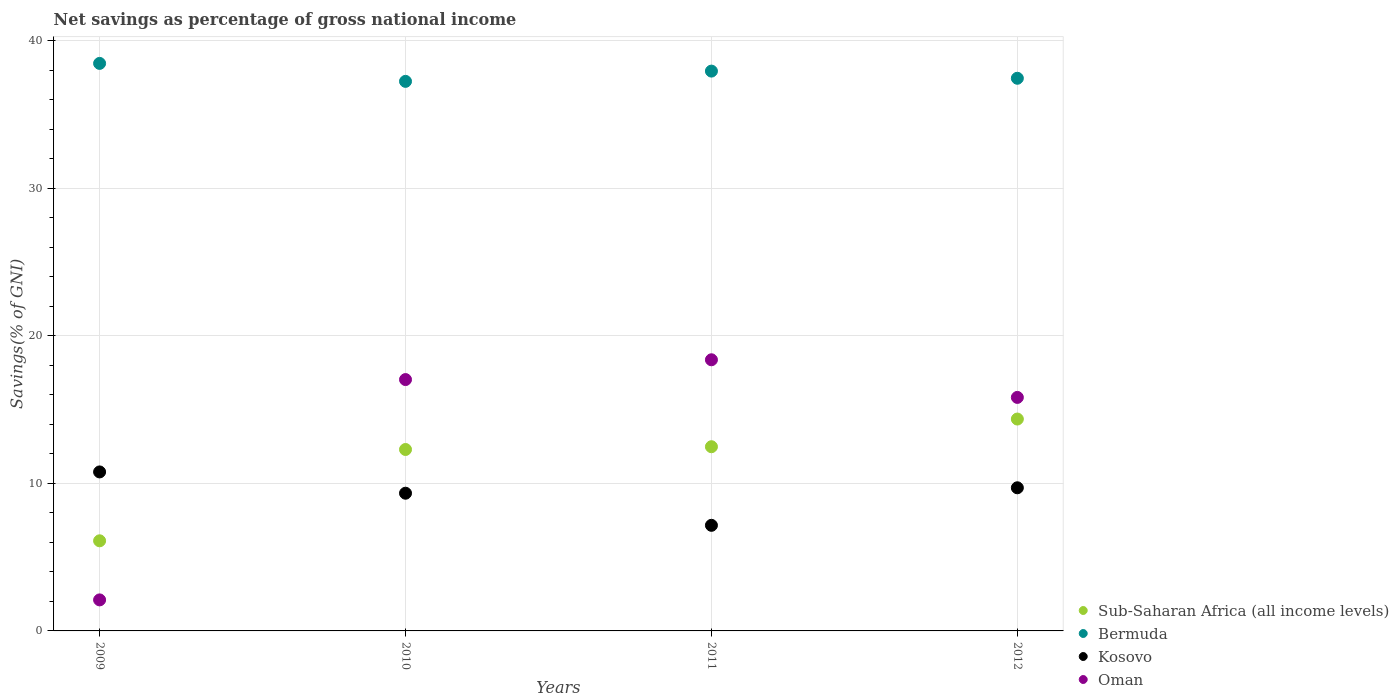How many different coloured dotlines are there?
Ensure brevity in your answer.  4. Is the number of dotlines equal to the number of legend labels?
Your answer should be compact. Yes. What is the total savings in Sub-Saharan Africa (all income levels) in 2010?
Your answer should be compact. 12.3. Across all years, what is the maximum total savings in Bermuda?
Give a very brief answer. 38.46. Across all years, what is the minimum total savings in Kosovo?
Ensure brevity in your answer.  7.16. In which year was the total savings in Oman maximum?
Your answer should be very brief. 2011. In which year was the total savings in Kosovo minimum?
Provide a short and direct response. 2011. What is the total total savings in Kosovo in the graph?
Offer a very short reply. 36.96. What is the difference between the total savings in Oman in 2010 and that in 2011?
Your answer should be compact. -1.34. What is the difference between the total savings in Kosovo in 2012 and the total savings in Oman in 2010?
Your answer should be very brief. -7.33. What is the average total savings in Oman per year?
Your answer should be very brief. 13.33. In the year 2009, what is the difference between the total savings in Oman and total savings in Bermuda?
Provide a short and direct response. -36.36. What is the ratio of the total savings in Kosovo in 2010 to that in 2012?
Provide a succinct answer. 0.96. What is the difference between the highest and the second highest total savings in Sub-Saharan Africa (all income levels)?
Provide a short and direct response. 1.88. What is the difference between the highest and the lowest total savings in Bermuda?
Keep it short and to the point. 1.22. Is the sum of the total savings in Kosovo in 2010 and 2012 greater than the maximum total savings in Oman across all years?
Make the answer very short. Yes. Is it the case that in every year, the sum of the total savings in Bermuda and total savings in Oman  is greater than the total savings in Kosovo?
Your answer should be compact. Yes. Does the total savings in Sub-Saharan Africa (all income levels) monotonically increase over the years?
Your response must be concise. Yes. How many years are there in the graph?
Keep it short and to the point. 4. What is the difference between two consecutive major ticks on the Y-axis?
Keep it short and to the point. 10. Are the values on the major ticks of Y-axis written in scientific E-notation?
Offer a terse response. No. Does the graph contain any zero values?
Offer a very short reply. No. How many legend labels are there?
Make the answer very short. 4. How are the legend labels stacked?
Ensure brevity in your answer.  Vertical. What is the title of the graph?
Give a very brief answer. Net savings as percentage of gross national income. What is the label or title of the Y-axis?
Your answer should be very brief. Savings(% of GNI). What is the Savings(% of GNI) in Sub-Saharan Africa (all income levels) in 2009?
Your answer should be very brief. 6.11. What is the Savings(% of GNI) of Bermuda in 2009?
Your answer should be compact. 38.46. What is the Savings(% of GNI) in Kosovo in 2009?
Keep it short and to the point. 10.77. What is the Savings(% of GNI) in Oman in 2009?
Offer a terse response. 2.1. What is the Savings(% of GNI) in Sub-Saharan Africa (all income levels) in 2010?
Ensure brevity in your answer.  12.3. What is the Savings(% of GNI) in Bermuda in 2010?
Keep it short and to the point. 37.24. What is the Savings(% of GNI) in Kosovo in 2010?
Make the answer very short. 9.33. What is the Savings(% of GNI) in Oman in 2010?
Your response must be concise. 17.03. What is the Savings(% of GNI) of Sub-Saharan Africa (all income levels) in 2011?
Offer a terse response. 12.48. What is the Savings(% of GNI) of Bermuda in 2011?
Ensure brevity in your answer.  37.94. What is the Savings(% of GNI) in Kosovo in 2011?
Offer a terse response. 7.16. What is the Savings(% of GNI) in Oman in 2011?
Provide a short and direct response. 18.38. What is the Savings(% of GNI) of Sub-Saharan Africa (all income levels) in 2012?
Your answer should be compact. 14.36. What is the Savings(% of GNI) in Bermuda in 2012?
Give a very brief answer. 37.45. What is the Savings(% of GNI) of Kosovo in 2012?
Your response must be concise. 9.7. What is the Savings(% of GNI) of Oman in 2012?
Your response must be concise. 15.83. Across all years, what is the maximum Savings(% of GNI) of Sub-Saharan Africa (all income levels)?
Make the answer very short. 14.36. Across all years, what is the maximum Savings(% of GNI) in Bermuda?
Provide a succinct answer. 38.46. Across all years, what is the maximum Savings(% of GNI) of Kosovo?
Ensure brevity in your answer.  10.77. Across all years, what is the maximum Savings(% of GNI) in Oman?
Provide a succinct answer. 18.38. Across all years, what is the minimum Savings(% of GNI) in Sub-Saharan Africa (all income levels)?
Offer a terse response. 6.11. Across all years, what is the minimum Savings(% of GNI) of Bermuda?
Ensure brevity in your answer.  37.24. Across all years, what is the minimum Savings(% of GNI) of Kosovo?
Offer a very short reply. 7.16. Across all years, what is the minimum Savings(% of GNI) of Oman?
Keep it short and to the point. 2.1. What is the total Savings(% of GNI) in Sub-Saharan Africa (all income levels) in the graph?
Make the answer very short. 45.24. What is the total Savings(% of GNI) of Bermuda in the graph?
Offer a very short reply. 151.09. What is the total Savings(% of GNI) in Kosovo in the graph?
Offer a very short reply. 36.96. What is the total Savings(% of GNI) of Oman in the graph?
Offer a terse response. 53.34. What is the difference between the Savings(% of GNI) in Sub-Saharan Africa (all income levels) in 2009 and that in 2010?
Offer a very short reply. -6.19. What is the difference between the Savings(% of GNI) in Bermuda in 2009 and that in 2010?
Your answer should be very brief. 1.22. What is the difference between the Savings(% of GNI) in Kosovo in 2009 and that in 2010?
Your response must be concise. 1.44. What is the difference between the Savings(% of GNI) of Oman in 2009 and that in 2010?
Ensure brevity in your answer.  -14.93. What is the difference between the Savings(% of GNI) in Sub-Saharan Africa (all income levels) in 2009 and that in 2011?
Offer a very short reply. -6.38. What is the difference between the Savings(% of GNI) in Bermuda in 2009 and that in 2011?
Provide a succinct answer. 0.52. What is the difference between the Savings(% of GNI) of Kosovo in 2009 and that in 2011?
Ensure brevity in your answer.  3.62. What is the difference between the Savings(% of GNI) in Oman in 2009 and that in 2011?
Your answer should be very brief. -16.27. What is the difference between the Savings(% of GNI) of Sub-Saharan Africa (all income levels) in 2009 and that in 2012?
Offer a very short reply. -8.25. What is the difference between the Savings(% of GNI) in Bermuda in 2009 and that in 2012?
Provide a short and direct response. 1.01. What is the difference between the Savings(% of GNI) in Kosovo in 2009 and that in 2012?
Offer a very short reply. 1.07. What is the difference between the Savings(% of GNI) of Oman in 2009 and that in 2012?
Offer a terse response. -13.72. What is the difference between the Savings(% of GNI) in Sub-Saharan Africa (all income levels) in 2010 and that in 2011?
Your response must be concise. -0.19. What is the difference between the Savings(% of GNI) of Bermuda in 2010 and that in 2011?
Provide a short and direct response. -0.7. What is the difference between the Savings(% of GNI) in Kosovo in 2010 and that in 2011?
Your answer should be very brief. 2.18. What is the difference between the Savings(% of GNI) in Oman in 2010 and that in 2011?
Provide a short and direct response. -1.34. What is the difference between the Savings(% of GNI) in Sub-Saharan Africa (all income levels) in 2010 and that in 2012?
Give a very brief answer. -2.06. What is the difference between the Savings(% of GNI) of Bermuda in 2010 and that in 2012?
Offer a very short reply. -0.21. What is the difference between the Savings(% of GNI) in Kosovo in 2010 and that in 2012?
Your response must be concise. -0.37. What is the difference between the Savings(% of GNI) in Oman in 2010 and that in 2012?
Provide a short and direct response. 1.21. What is the difference between the Savings(% of GNI) of Sub-Saharan Africa (all income levels) in 2011 and that in 2012?
Your answer should be very brief. -1.88. What is the difference between the Savings(% of GNI) in Bermuda in 2011 and that in 2012?
Offer a very short reply. 0.49. What is the difference between the Savings(% of GNI) in Kosovo in 2011 and that in 2012?
Your answer should be very brief. -2.54. What is the difference between the Savings(% of GNI) in Oman in 2011 and that in 2012?
Your answer should be very brief. 2.55. What is the difference between the Savings(% of GNI) of Sub-Saharan Africa (all income levels) in 2009 and the Savings(% of GNI) of Bermuda in 2010?
Provide a short and direct response. -31.14. What is the difference between the Savings(% of GNI) in Sub-Saharan Africa (all income levels) in 2009 and the Savings(% of GNI) in Kosovo in 2010?
Your answer should be very brief. -3.23. What is the difference between the Savings(% of GNI) of Sub-Saharan Africa (all income levels) in 2009 and the Savings(% of GNI) of Oman in 2010?
Ensure brevity in your answer.  -10.93. What is the difference between the Savings(% of GNI) in Bermuda in 2009 and the Savings(% of GNI) in Kosovo in 2010?
Keep it short and to the point. 29.13. What is the difference between the Savings(% of GNI) in Bermuda in 2009 and the Savings(% of GNI) in Oman in 2010?
Keep it short and to the point. 21.43. What is the difference between the Savings(% of GNI) of Kosovo in 2009 and the Savings(% of GNI) of Oman in 2010?
Your response must be concise. -6.26. What is the difference between the Savings(% of GNI) in Sub-Saharan Africa (all income levels) in 2009 and the Savings(% of GNI) in Bermuda in 2011?
Provide a short and direct response. -31.83. What is the difference between the Savings(% of GNI) of Sub-Saharan Africa (all income levels) in 2009 and the Savings(% of GNI) of Kosovo in 2011?
Offer a terse response. -1.05. What is the difference between the Savings(% of GNI) in Sub-Saharan Africa (all income levels) in 2009 and the Savings(% of GNI) in Oman in 2011?
Your answer should be compact. -12.27. What is the difference between the Savings(% of GNI) in Bermuda in 2009 and the Savings(% of GNI) in Kosovo in 2011?
Your answer should be very brief. 31.3. What is the difference between the Savings(% of GNI) in Bermuda in 2009 and the Savings(% of GNI) in Oman in 2011?
Give a very brief answer. 20.09. What is the difference between the Savings(% of GNI) of Kosovo in 2009 and the Savings(% of GNI) of Oman in 2011?
Keep it short and to the point. -7.6. What is the difference between the Savings(% of GNI) of Sub-Saharan Africa (all income levels) in 2009 and the Savings(% of GNI) of Bermuda in 2012?
Offer a terse response. -31.35. What is the difference between the Savings(% of GNI) of Sub-Saharan Africa (all income levels) in 2009 and the Savings(% of GNI) of Kosovo in 2012?
Offer a very short reply. -3.59. What is the difference between the Savings(% of GNI) in Sub-Saharan Africa (all income levels) in 2009 and the Savings(% of GNI) in Oman in 2012?
Your answer should be compact. -9.72. What is the difference between the Savings(% of GNI) in Bermuda in 2009 and the Savings(% of GNI) in Kosovo in 2012?
Your response must be concise. 28.76. What is the difference between the Savings(% of GNI) in Bermuda in 2009 and the Savings(% of GNI) in Oman in 2012?
Provide a short and direct response. 22.63. What is the difference between the Savings(% of GNI) of Kosovo in 2009 and the Savings(% of GNI) of Oman in 2012?
Offer a very short reply. -5.05. What is the difference between the Savings(% of GNI) of Sub-Saharan Africa (all income levels) in 2010 and the Savings(% of GNI) of Bermuda in 2011?
Offer a terse response. -25.64. What is the difference between the Savings(% of GNI) of Sub-Saharan Africa (all income levels) in 2010 and the Savings(% of GNI) of Kosovo in 2011?
Your response must be concise. 5.14. What is the difference between the Savings(% of GNI) in Sub-Saharan Africa (all income levels) in 2010 and the Savings(% of GNI) in Oman in 2011?
Your response must be concise. -6.08. What is the difference between the Savings(% of GNI) in Bermuda in 2010 and the Savings(% of GNI) in Kosovo in 2011?
Your response must be concise. 30.09. What is the difference between the Savings(% of GNI) in Bermuda in 2010 and the Savings(% of GNI) in Oman in 2011?
Offer a very short reply. 18.87. What is the difference between the Savings(% of GNI) in Kosovo in 2010 and the Savings(% of GNI) in Oman in 2011?
Provide a succinct answer. -9.04. What is the difference between the Savings(% of GNI) of Sub-Saharan Africa (all income levels) in 2010 and the Savings(% of GNI) of Bermuda in 2012?
Provide a succinct answer. -25.16. What is the difference between the Savings(% of GNI) of Sub-Saharan Africa (all income levels) in 2010 and the Savings(% of GNI) of Kosovo in 2012?
Your answer should be very brief. 2.6. What is the difference between the Savings(% of GNI) of Sub-Saharan Africa (all income levels) in 2010 and the Savings(% of GNI) of Oman in 2012?
Offer a terse response. -3.53. What is the difference between the Savings(% of GNI) in Bermuda in 2010 and the Savings(% of GNI) in Kosovo in 2012?
Provide a short and direct response. 27.54. What is the difference between the Savings(% of GNI) of Bermuda in 2010 and the Savings(% of GNI) of Oman in 2012?
Ensure brevity in your answer.  21.42. What is the difference between the Savings(% of GNI) in Kosovo in 2010 and the Savings(% of GNI) in Oman in 2012?
Make the answer very short. -6.49. What is the difference between the Savings(% of GNI) of Sub-Saharan Africa (all income levels) in 2011 and the Savings(% of GNI) of Bermuda in 2012?
Your answer should be very brief. -24.97. What is the difference between the Savings(% of GNI) of Sub-Saharan Africa (all income levels) in 2011 and the Savings(% of GNI) of Kosovo in 2012?
Provide a short and direct response. 2.78. What is the difference between the Savings(% of GNI) in Sub-Saharan Africa (all income levels) in 2011 and the Savings(% of GNI) in Oman in 2012?
Provide a succinct answer. -3.34. What is the difference between the Savings(% of GNI) of Bermuda in 2011 and the Savings(% of GNI) of Kosovo in 2012?
Your response must be concise. 28.24. What is the difference between the Savings(% of GNI) in Bermuda in 2011 and the Savings(% of GNI) in Oman in 2012?
Keep it short and to the point. 22.11. What is the difference between the Savings(% of GNI) of Kosovo in 2011 and the Savings(% of GNI) of Oman in 2012?
Your answer should be compact. -8.67. What is the average Savings(% of GNI) of Sub-Saharan Africa (all income levels) per year?
Provide a succinct answer. 11.31. What is the average Savings(% of GNI) in Bermuda per year?
Provide a short and direct response. 37.77. What is the average Savings(% of GNI) in Kosovo per year?
Provide a succinct answer. 9.24. What is the average Savings(% of GNI) of Oman per year?
Provide a short and direct response. 13.33. In the year 2009, what is the difference between the Savings(% of GNI) of Sub-Saharan Africa (all income levels) and Savings(% of GNI) of Bermuda?
Provide a short and direct response. -32.35. In the year 2009, what is the difference between the Savings(% of GNI) in Sub-Saharan Africa (all income levels) and Savings(% of GNI) in Kosovo?
Offer a very short reply. -4.67. In the year 2009, what is the difference between the Savings(% of GNI) in Sub-Saharan Africa (all income levels) and Savings(% of GNI) in Oman?
Offer a very short reply. 4. In the year 2009, what is the difference between the Savings(% of GNI) in Bermuda and Savings(% of GNI) in Kosovo?
Your answer should be compact. 27.69. In the year 2009, what is the difference between the Savings(% of GNI) in Bermuda and Savings(% of GNI) in Oman?
Make the answer very short. 36.36. In the year 2009, what is the difference between the Savings(% of GNI) of Kosovo and Savings(% of GNI) of Oman?
Provide a short and direct response. 8.67. In the year 2010, what is the difference between the Savings(% of GNI) of Sub-Saharan Africa (all income levels) and Savings(% of GNI) of Bermuda?
Provide a succinct answer. -24.95. In the year 2010, what is the difference between the Savings(% of GNI) in Sub-Saharan Africa (all income levels) and Savings(% of GNI) in Kosovo?
Provide a succinct answer. 2.96. In the year 2010, what is the difference between the Savings(% of GNI) in Sub-Saharan Africa (all income levels) and Savings(% of GNI) in Oman?
Provide a succinct answer. -4.74. In the year 2010, what is the difference between the Savings(% of GNI) of Bermuda and Savings(% of GNI) of Kosovo?
Your answer should be compact. 27.91. In the year 2010, what is the difference between the Savings(% of GNI) in Bermuda and Savings(% of GNI) in Oman?
Your response must be concise. 20.21. In the year 2010, what is the difference between the Savings(% of GNI) in Kosovo and Savings(% of GNI) in Oman?
Your answer should be compact. -7.7. In the year 2011, what is the difference between the Savings(% of GNI) of Sub-Saharan Africa (all income levels) and Savings(% of GNI) of Bermuda?
Provide a short and direct response. -25.45. In the year 2011, what is the difference between the Savings(% of GNI) of Sub-Saharan Africa (all income levels) and Savings(% of GNI) of Kosovo?
Offer a very short reply. 5.33. In the year 2011, what is the difference between the Savings(% of GNI) in Sub-Saharan Africa (all income levels) and Savings(% of GNI) in Oman?
Your answer should be compact. -5.89. In the year 2011, what is the difference between the Savings(% of GNI) in Bermuda and Savings(% of GNI) in Kosovo?
Provide a short and direct response. 30.78. In the year 2011, what is the difference between the Savings(% of GNI) in Bermuda and Savings(% of GNI) in Oman?
Make the answer very short. 19.56. In the year 2011, what is the difference between the Savings(% of GNI) of Kosovo and Savings(% of GNI) of Oman?
Make the answer very short. -11.22. In the year 2012, what is the difference between the Savings(% of GNI) in Sub-Saharan Africa (all income levels) and Savings(% of GNI) in Bermuda?
Your answer should be compact. -23.09. In the year 2012, what is the difference between the Savings(% of GNI) in Sub-Saharan Africa (all income levels) and Savings(% of GNI) in Kosovo?
Keep it short and to the point. 4.66. In the year 2012, what is the difference between the Savings(% of GNI) in Sub-Saharan Africa (all income levels) and Savings(% of GNI) in Oman?
Give a very brief answer. -1.47. In the year 2012, what is the difference between the Savings(% of GNI) of Bermuda and Savings(% of GNI) of Kosovo?
Your answer should be compact. 27.75. In the year 2012, what is the difference between the Savings(% of GNI) of Bermuda and Savings(% of GNI) of Oman?
Keep it short and to the point. 21.63. In the year 2012, what is the difference between the Savings(% of GNI) of Kosovo and Savings(% of GNI) of Oman?
Provide a short and direct response. -6.12. What is the ratio of the Savings(% of GNI) of Sub-Saharan Africa (all income levels) in 2009 to that in 2010?
Offer a terse response. 0.5. What is the ratio of the Savings(% of GNI) in Bermuda in 2009 to that in 2010?
Keep it short and to the point. 1.03. What is the ratio of the Savings(% of GNI) in Kosovo in 2009 to that in 2010?
Provide a short and direct response. 1.15. What is the ratio of the Savings(% of GNI) in Oman in 2009 to that in 2010?
Provide a short and direct response. 0.12. What is the ratio of the Savings(% of GNI) in Sub-Saharan Africa (all income levels) in 2009 to that in 2011?
Give a very brief answer. 0.49. What is the ratio of the Savings(% of GNI) of Bermuda in 2009 to that in 2011?
Provide a succinct answer. 1.01. What is the ratio of the Savings(% of GNI) of Kosovo in 2009 to that in 2011?
Ensure brevity in your answer.  1.51. What is the ratio of the Savings(% of GNI) in Oman in 2009 to that in 2011?
Ensure brevity in your answer.  0.11. What is the ratio of the Savings(% of GNI) in Sub-Saharan Africa (all income levels) in 2009 to that in 2012?
Your answer should be compact. 0.43. What is the ratio of the Savings(% of GNI) of Bermuda in 2009 to that in 2012?
Your response must be concise. 1.03. What is the ratio of the Savings(% of GNI) in Kosovo in 2009 to that in 2012?
Provide a short and direct response. 1.11. What is the ratio of the Savings(% of GNI) of Oman in 2009 to that in 2012?
Make the answer very short. 0.13. What is the ratio of the Savings(% of GNI) in Sub-Saharan Africa (all income levels) in 2010 to that in 2011?
Your answer should be compact. 0.98. What is the ratio of the Savings(% of GNI) of Bermuda in 2010 to that in 2011?
Make the answer very short. 0.98. What is the ratio of the Savings(% of GNI) of Kosovo in 2010 to that in 2011?
Provide a succinct answer. 1.3. What is the ratio of the Savings(% of GNI) of Oman in 2010 to that in 2011?
Your answer should be compact. 0.93. What is the ratio of the Savings(% of GNI) of Sub-Saharan Africa (all income levels) in 2010 to that in 2012?
Make the answer very short. 0.86. What is the ratio of the Savings(% of GNI) in Kosovo in 2010 to that in 2012?
Provide a succinct answer. 0.96. What is the ratio of the Savings(% of GNI) in Oman in 2010 to that in 2012?
Provide a succinct answer. 1.08. What is the ratio of the Savings(% of GNI) in Sub-Saharan Africa (all income levels) in 2011 to that in 2012?
Your response must be concise. 0.87. What is the ratio of the Savings(% of GNI) of Kosovo in 2011 to that in 2012?
Offer a very short reply. 0.74. What is the ratio of the Savings(% of GNI) in Oman in 2011 to that in 2012?
Keep it short and to the point. 1.16. What is the difference between the highest and the second highest Savings(% of GNI) of Sub-Saharan Africa (all income levels)?
Offer a very short reply. 1.88. What is the difference between the highest and the second highest Savings(% of GNI) of Bermuda?
Offer a very short reply. 0.52. What is the difference between the highest and the second highest Savings(% of GNI) in Kosovo?
Offer a terse response. 1.07. What is the difference between the highest and the second highest Savings(% of GNI) in Oman?
Give a very brief answer. 1.34. What is the difference between the highest and the lowest Savings(% of GNI) of Sub-Saharan Africa (all income levels)?
Make the answer very short. 8.25. What is the difference between the highest and the lowest Savings(% of GNI) in Bermuda?
Provide a succinct answer. 1.22. What is the difference between the highest and the lowest Savings(% of GNI) of Kosovo?
Your response must be concise. 3.62. What is the difference between the highest and the lowest Savings(% of GNI) of Oman?
Ensure brevity in your answer.  16.27. 